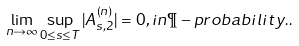<formula> <loc_0><loc_0><loc_500><loc_500>\lim _ { n \to \infty } \sup _ { 0 \leq s \leq T } | A _ { s , 2 } ^ { ( n ) } | = 0 , i n \P - p r o b a b i l i t y . .</formula> 